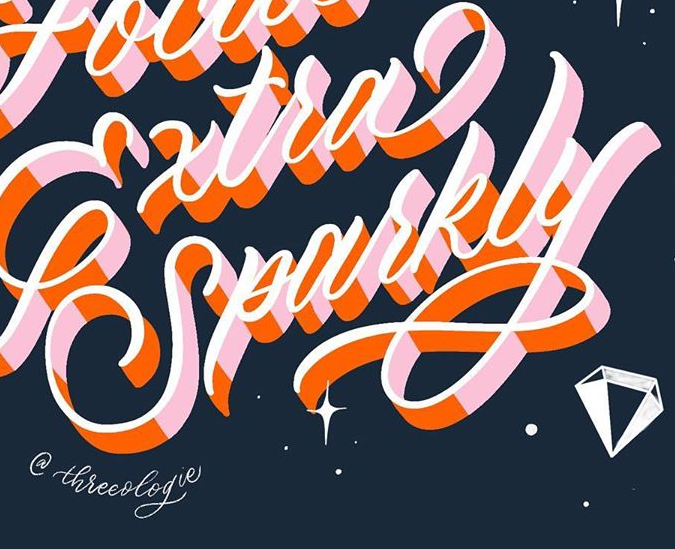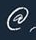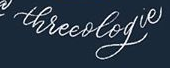What words can you see in these images in sequence, separated by a semicolon? Sparkly; @; threeologie 